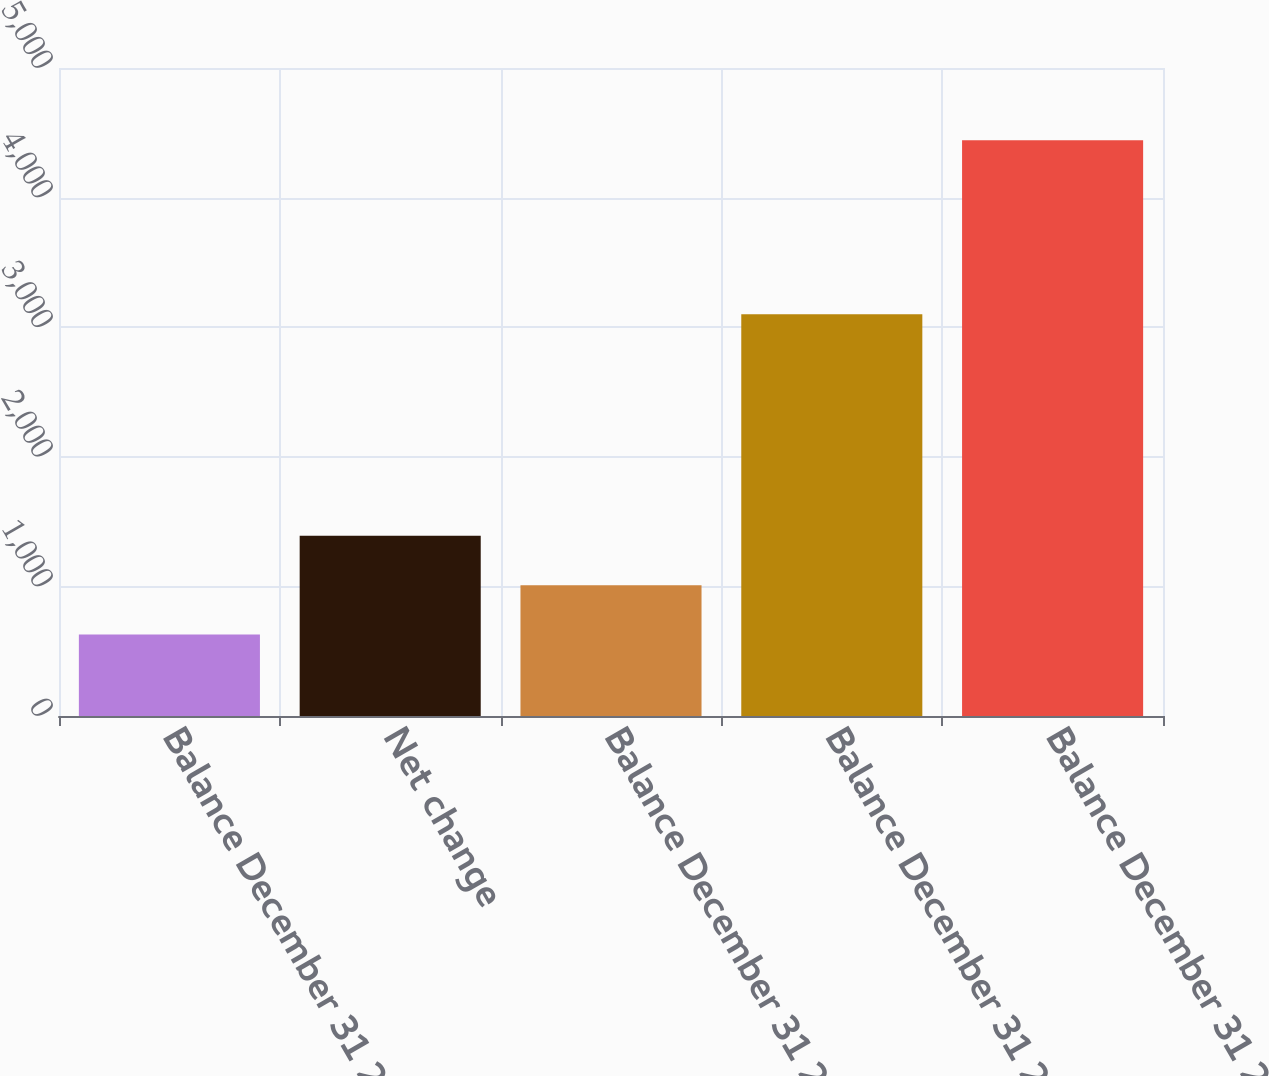Convert chart. <chart><loc_0><loc_0><loc_500><loc_500><bar_chart><fcel>Balance December 31 2009<fcel>Net change<fcel>Balance December 31 2010<fcel>Balance December 31 2011<fcel>Balance December 31 2012<nl><fcel>628<fcel>1391<fcel>1009.5<fcel>3100<fcel>4443<nl></chart> 